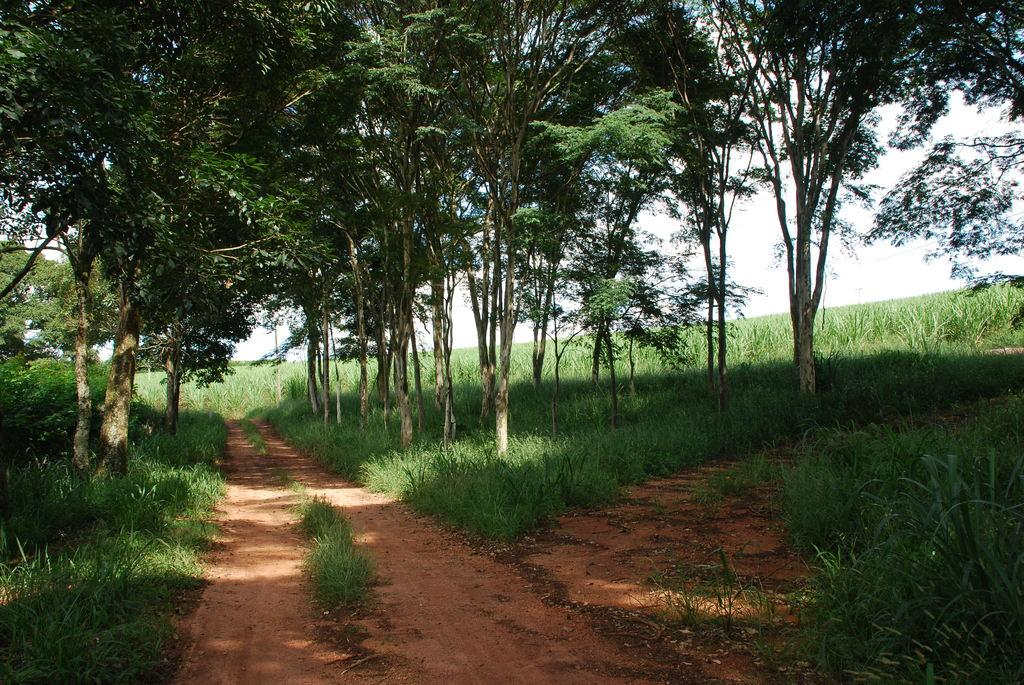What type of vegetation can be seen in the image? There are trees and plants in the image. What is covering the ground in the image? There is grass on the ground in the image. What can be seen in the background of the image? The sky is visible in the background of the image. Can you hear the owl laughing in the image? There is no owl or laughter present in the image; it features trees, plants, grass, and the sky. 